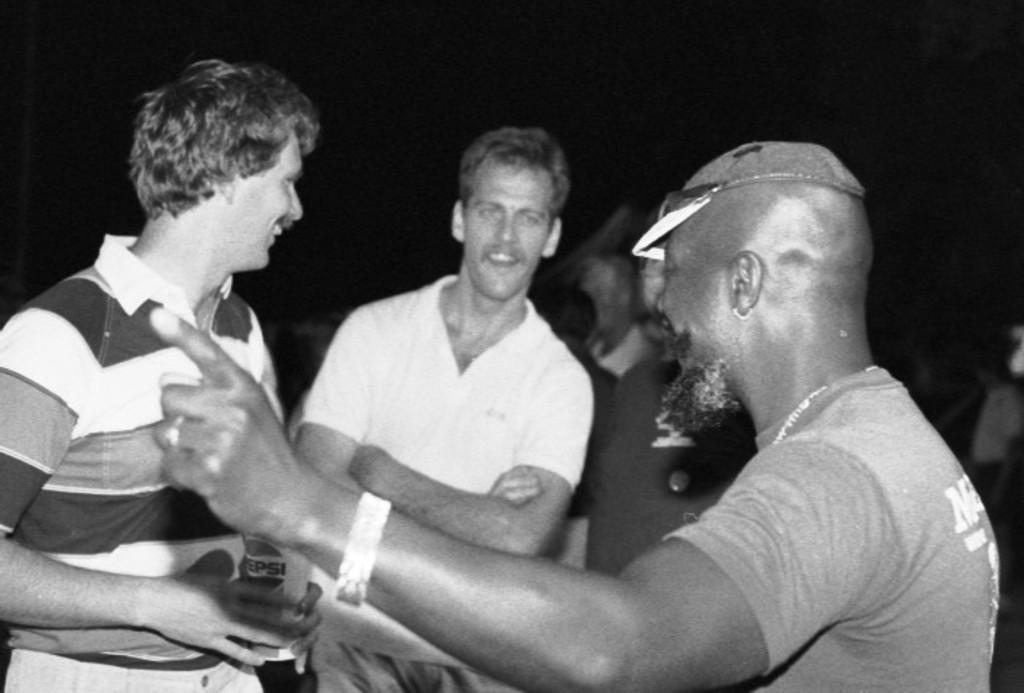In one or two sentences, can you explain what this image depicts? In this image I can see number of people are standing. In the front I can see one of them is wearing a cap. On the left side of this image I can see one person is holding a glass and I can see this image is black and white in colour. 